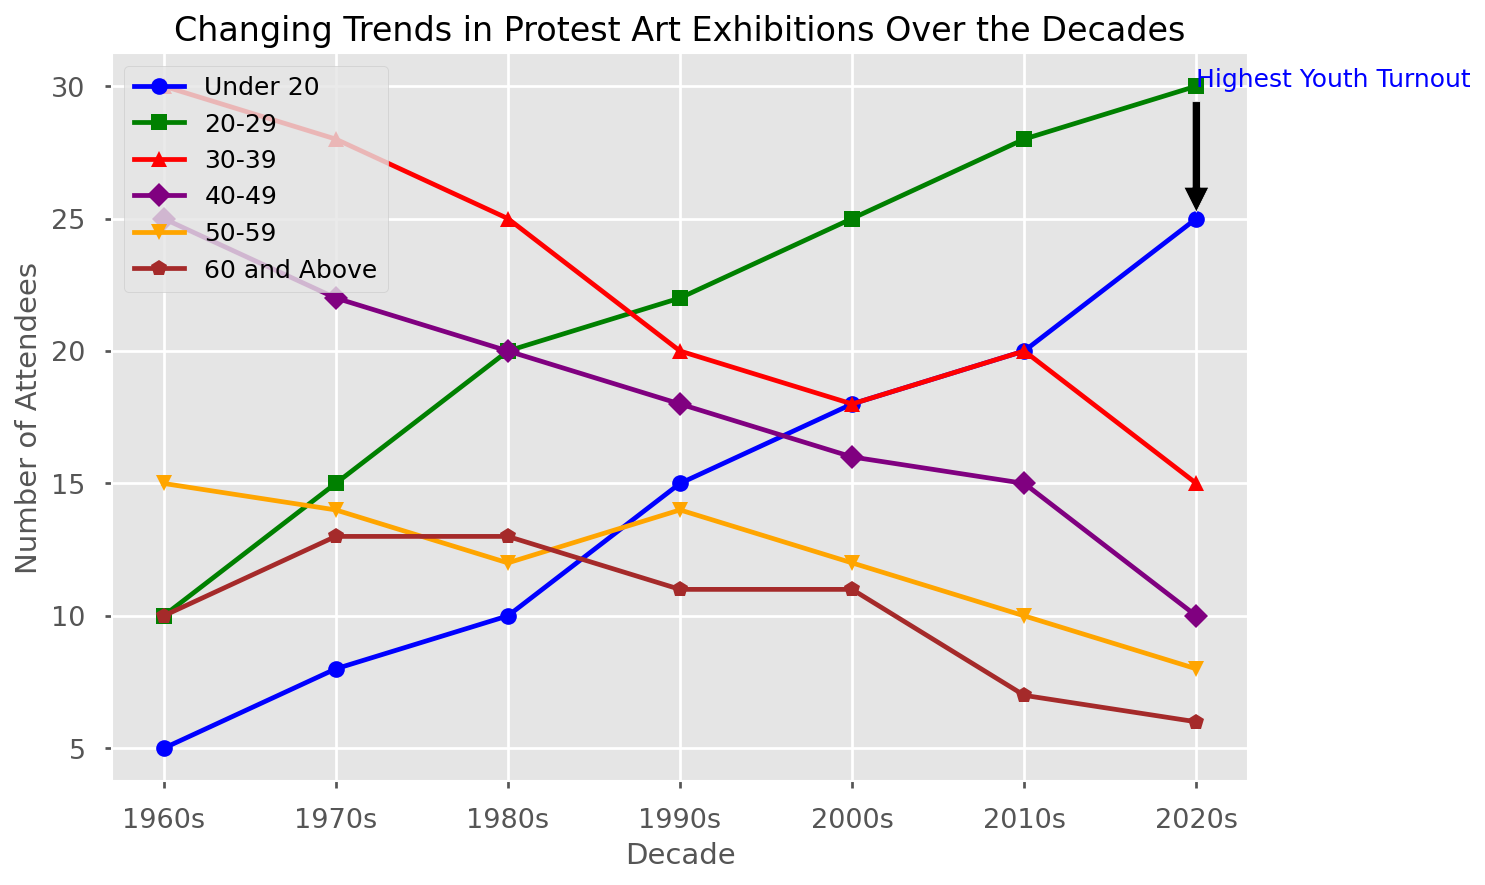When did the highest youth turnout occur? The highest youth turnout is annotated in the figure with an arrow and a text annotation indicating "Highest Youth Turnout." The text annotation points to the 2020s.
Answer: 2020s Which decade had the most attendees overall? To find the decade with the most attendees overall, add the values for each age group in each decade and compare the totals. The sum for each decade is as follows: 
1960s: 95 
1970s: 100 
1980s: 100 
1990s: 100 
2000s: 100 
2010s: 100 
2020s: 94
The 1970s, 1980s, 1990s, and 2000s each had the same highest total attendees.
Answer: 1970s, 1980s, 1990s, 2000s Which age group saw a decrease in attendees from the 1960s to the 2020s? Compare the values for each age group in the 1960s and 2020s:
Under 20: 5 to 25 (increase)
20-29: 10 to 30 (increase)
30-39: 30 to 15 (decrease)
40-49: 25 to 10 (decrease)
50-59: 15 to 8 (decrease)
60 and Above: 10 to 6 (decrease)
Answer: 30-39, 40-49, 50-59, 60 and Above What is the total number of attendees in the 40-49 age group from the 1960s to the 2020s? Sum the values for the 40-49 age group across all decades: 
25 (1960s) + 22 (1970s) + 20 (1980s) + 18 (1990s) + 16 (2000s) + 15 (2010s) + 10 (2020s) = 126
Answer: 126 Which decade saw the highest number of attendees in the 20-29 age group? By comparing the values for the 20-29 age group across all decades, the highest value is in the 2020s with 30 attendees.
Answer: 2020s What is the average number of attendees in the 20-29 age group across all decades? Sum the number of attendees in the 20-29 age group across all decades and divide by the number of decades:
10 (1960s) + 15 (1970s) + 20 (1980s) + 22 (1990s) + 25 (2000s) + 28 (2010s) + 30 (2020s) = 150
150 / 7 = 21.43
Answer: 21.43 In which decade did the 30-39 age group have the highest number of attendees? By comparing the values for the 30-39 age group across all decades, the highest value is in the 1960s with 30 attendees.
Answer: 1960s 